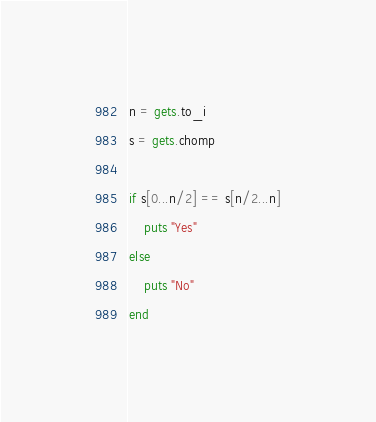Convert code to text. <code><loc_0><loc_0><loc_500><loc_500><_Ruby_>n = gets.to_i
s = gets.chomp

if s[0...n/2] == s[n/2...n]
    puts "Yes"
else
    puts "No"
end</code> 